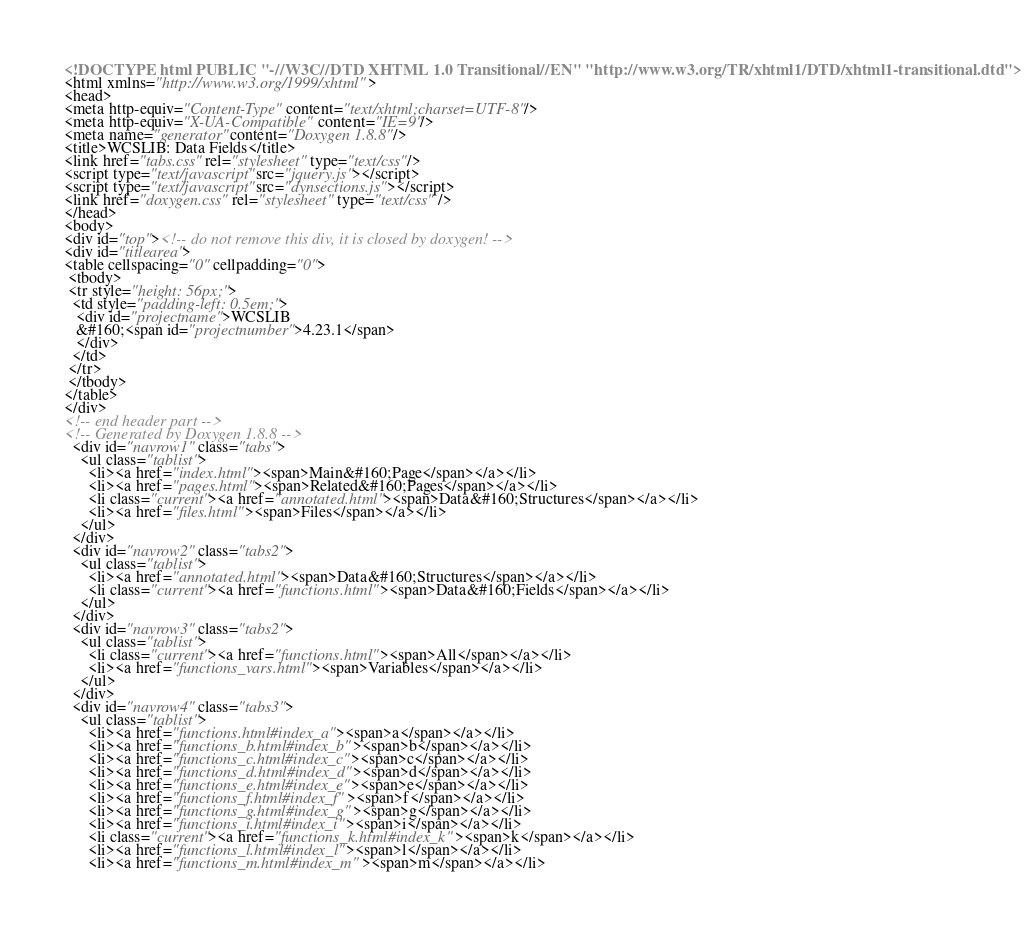<code> <loc_0><loc_0><loc_500><loc_500><_HTML_><!DOCTYPE html PUBLIC "-//W3C//DTD XHTML 1.0 Transitional//EN" "http://www.w3.org/TR/xhtml1/DTD/xhtml1-transitional.dtd">
<html xmlns="http://www.w3.org/1999/xhtml">
<head>
<meta http-equiv="Content-Type" content="text/xhtml;charset=UTF-8"/>
<meta http-equiv="X-UA-Compatible" content="IE=9"/>
<meta name="generator" content="Doxygen 1.8.8"/>
<title>WCSLIB: Data Fields</title>
<link href="tabs.css" rel="stylesheet" type="text/css"/>
<script type="text/javascript" src="jquery.js"></script>
<script type="text/javascript" src="dynsections.js"></script>
<link href="doxygen.css" rel="stylesheet" type="text/css" />
</head>
<body>
<div id="top"><!-- do not remove this div, it is closed by doxygen! -->
<div id="titlearea">
<table cellspacing="0" cellpadding="0">
 <tbody>
 <tr style="height: 56px;">
  <td style="padding-left: 0.5em;">
   <div id="projectname">WCSLIB
   &#160;<span id="projectnumber">4.23.1</span>
   </div>
  </td>
 </tr>
 </tbody>
</table>
</div>
<!-- end header part -->
<!-- Generated by Doxygen 1.8.8 -->
  <div id="navrow1" class="tabs">
    <ul class="tablist">
      <li><a href="index.html"><span>Main&#160;Page</span></a></li>
      <li><a href="pages.html"><span>Related&#160;Pages</span></a></li>
      <li class="current"><a href="annotated.html"><span>Data&#160;Structures</span></a></li>
      <li><a href="files.html"><span>Files</span></a></li>
    </ul>
  </div>
  <div id="navrow2" class="tabs2">
    <ul class="tablist">
      <li><a href="annotated.html"><span>Data&#160;Structures</span></a></li>
      <li class="current"><a href="functions.html"><span>Data&#160;Fields</span></a></li>
    </ul>
  </div>
  <div id="navrow3" class="tabs2">
    <ul class="tablist">
      <li class="current"><a href="functions.html"><span>All</span></a></li>
      <li><a href="functions_vars.html"><span>Variables</span></a></li>
    </ul>
  </div>
  <div id="navrow4" class="tabs3">
    <ul class="tablist">
      <li><a href="functions.html#index_a"><span>a</span></a></li>
      <li><a href="functions_b.html#index_b"><span>b</span></a></li>
      <li><a href="functions_c.html#index_c"><span>c</span></a></li>
      <li><a href="functions_d.html#index_d"><span>d</span></a></li>
      <li><a href="functions_e.html#index_e"><span>e</span></a></li>
      <li><a href="functions_f.html#index_f"><span>f</span></a></li>
      <li><a href="functions_g.html#index_g"><span>g</span></a></li>
      <li><a href="functions_i.html#index_i"><span>i</span></a></li>
      <li class="current"><a href="functions_k.html#index_k"><span>k</span></a></li>
      <li><a href="functions_l.html#index_l"><span>l</span></a></li>
      <li><a href="functions_m.html#index_m"><span>m</span></a></li></code> 